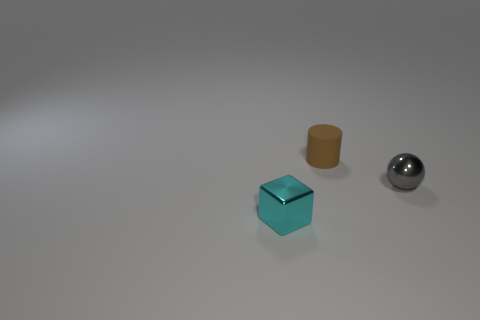Are there any brown things that have the same size as the sphere?
Offer a terse response. Yes. Are there fewer tiny purple rubber cylinders than gray things?
Offer a very short reply. Yes. The metal object in front of the shiny thing that is behind the metallic object to the left of the brown thing is what shape?
Provide a succinct answer. Cube. What number of objects are either small gray metallic balls that are on the right side of the small brown object or metallic things that are behind the cyan metallic thing?
Make the answer very short. 1. Are there any brown rubber objects right of the shiny block?
Give a very brief answer. Yes. How many objects are shiny objects in front of the shiny ball or big red metal spheres?
Provide a succinct answer. 1. How many gray objects are either blocks or small shiny objects?
Provide a short and direct response. 1. What number of other objects are there of the same color as the matte object?
Offer a very short reply. 0. Is the number of tiny gray spheres behind the brown cylinder less than the number of tiny cyan metallic cubes?
Your answer should be very brief. Yes. What is the color of the object in front of the tiny metallic thing that is behind the small shiny thing that is to the left of the tiny gray thing?
Provide a succinct answer. Cyan. 